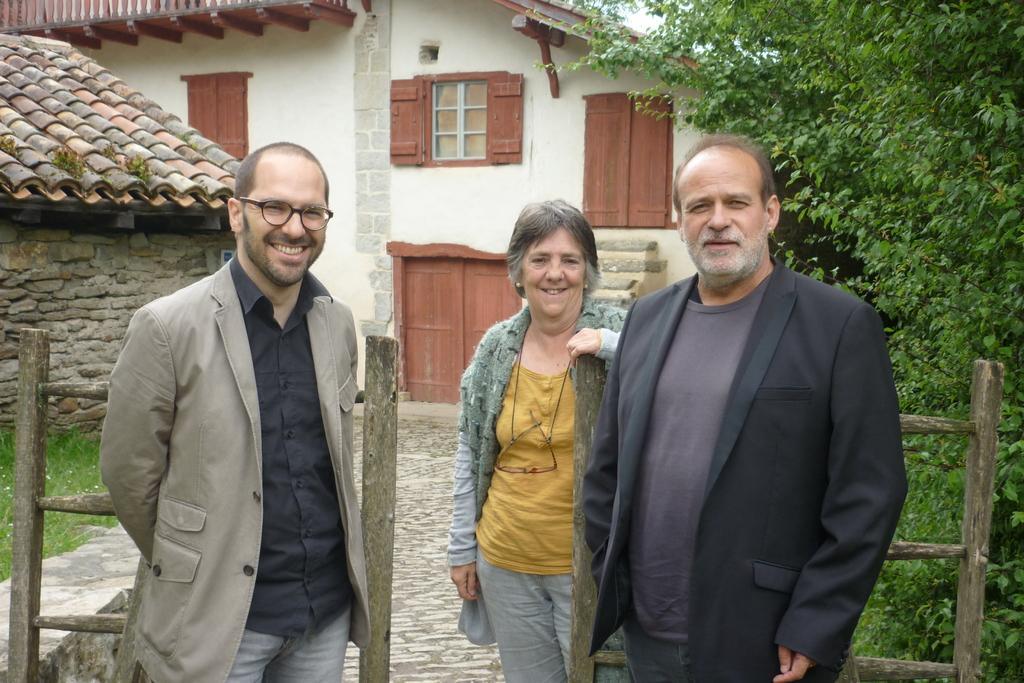Can you describe this image briefly? In the foreground of this image, there are two men and a woman standing near a wooden railing. In the background, there is a house, a hut, grass and trees. 